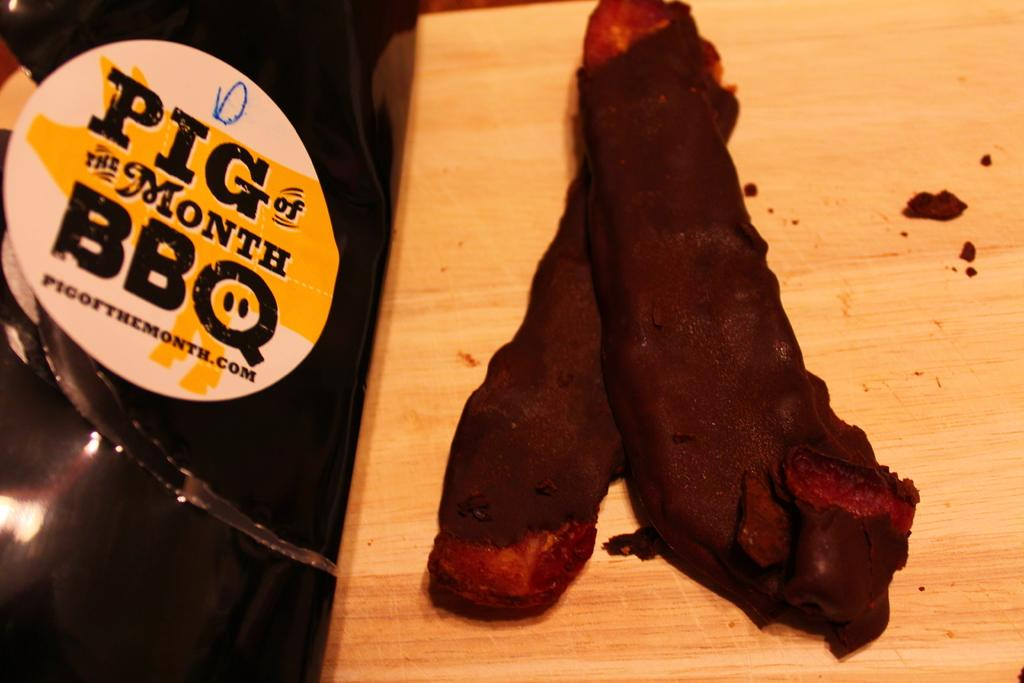What type of food can be seen in the image? The food in the image is brown in color. What is the color of the surface on which the food is placed? The food is on a brown surface. Can you describe the sticker in the image? There is a sticker attached to an object in the image, and the object is black in color. What type of parent is depicted in the image? There is no parent depicted in the image; it only features food, a brown surface, and a sticker on a black object. 